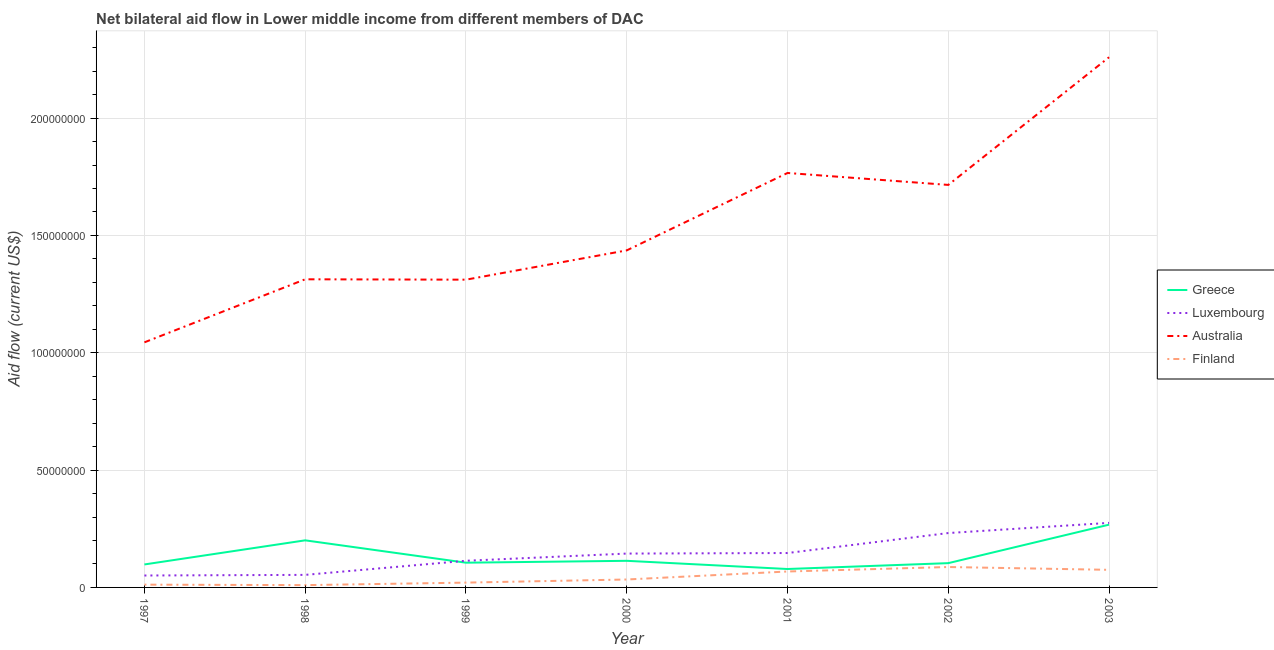How many different coloured lines are there?
Your answer should be compact. 4. Does the line corresponding to amount of aid given by luxembourg intersect with the line corresponding to amount of aid given by australia?
Keep it short and to the point. No. What is the amount of aid given by greece in 2002?
Offer a very short reply. 1.04e+07. Across all years, what is the maximum amount of aid given by greece?
Your response must be concise. 2.68e+07. Across all years, what is the minimum amount of aid given by finland?
Your response must be concise. 9.80e+05. In which year was the amount of aid given by greece maximum?
Make the answer very short. 2003. What is the total amount of aid given by greece in the graph?
Offer a very short reply. 9.67e+07. What is the difference between the amount of aid given by luxembourg in 1997 and that in 1999?
Keep it short and to the point. -6.28e+06. What is the difference between the amount of aid given by finland in 1997 and the amount of aid given by luxembourg in 2003?
Your answer should be very brief. -2.63e+07. What is the average amount of aid given by australia per year?
Your answer should be very brief. 1.55e+08. In the year 1997, what is the difference between the amount of aid given by australia and amount of aid given by greece?
Provide a short and direct response. 9.47e+07. What is the ratio of the amount of aid given by greece in 1997 to that in 2003?
Make the answer very short. 0.37. What is the difference between the highest and the second highest amount of aid given by australia?
Keep it short and to the point. 4.93e+07. What is the difference between the highest and the lowest amount of aid given by luxembourg?
Your answer should be very brief. 2.24e+07. In how many years, is the amount of aid given by luxembourg greater than the average amount of aid given by luxembourg taken over all years?
Your answer should be very brief. 3. Is the sum of the amount of aid given by australia in 2001 and 2003 greater than the maximum amount of aid given by finland across all years?
Your answer should be very brief. Yes. Is it the case that in every year, the sum of the amount of aid given by australia and amount of aid given by luxembourg is greater than the sum of amount of aid given by finland and amount of aid given by greece?
Your answer should be very brief. No. Does the amount of aid given by australia monotonically increase over the years?
Offer a very short reply. No. Is the amount of aid given by greece strictly greater than the amount of aid given by luxembourg over the years?
Offer a terse response. No. What is the difference between two consecutive major ticks on the Y-axis?
Ensure brevity in your answer.  5.00e+07. Does the graph contain any zero values?
Your answer should be compact. No. Where does the legend appear in the graph?
Ensure brevity in your answer.  Center right. How many legend labels are there?
Your answer should be very brief. 4. How are the legend labels stacked?
Ensure brevity in your answer.  Vertical. What is the title of the graph?
Your answer should be compact. Net bilateral aid flow in Lower middle income from different members of DAC. Does "Interest Payments" appear as one of the legend labels in the graph?
Your answer should be compact. No. What is the Aid flow (current US$) of Greece in 1997?
Provide a succinct answer. 9.79e+06. What is the Aid flow (current US$) in Luxembourg in 1997?
Make the answer very short. 5.08e+06. What is the Aid flow (current US$) of Australia in 1997?
Offer a terse response. 1.04e+08. What is the Aid flow (current US$) of Finland in 1997?
Your answer should be compact. 1.18e+06. What is the Aid flow (current US$) of Greece in 1998?
Give a very brief answer. 2.01e+07. What is the Aid flow (current US$) of Luxembourg in 1998?
Keep it short and to the point. 5.35e+06. What is the Aid flow (current US$) in Australia in 1998?
Your answer should be compact. 1.31e+08. What is the Aid flow (current US$) in Finland in 1998?
Ensure brevity in your answer.  9.80e+05. What is the Aid flow (current US$) in Greece in 1999?
Make the answer very short. 1.05e+07. What is the Aid flow (current US$) in Luxembourg in 1999?
Your answer should be compact. 1.14e+07. What is the Aid flow (current US$) in Australia in 1999?
Give a very brief answer. 1.31e+08. What is the Aid flow (current US$) of Finland in 1999?
Provide a succinct answer. 2.05e+06. What is the Aid flow (current US$) of Greece in 2000?
Keep it short and to the point. 1.13e+07. What is the Aid flow (current US$) in Luxembourg in 2000?
Your answer should be compact. 1.44e+07. What is the Aid flow (current US$) of Australia in 2000?
Ensure brevity in your answer.  1.44e+08. What is the Aid flow (current US$) of Finland in 2000?
Give a very brief answer. 3.38e+06. What is the Aid flow (current US$) in Greece in 2001?
Your answer should be very brief. 7.85e+06. What is the Aid flow (current US$) in Luxembourg in 2001?
Keep it short and to the point. 1.47e+07. What is the Aid flow (current US$) of Australia in 2001?
Your response must be concise. 1.77e+08. What is the Aid flow (current US$) in Finland in 2001?
Your answer should be very brief. 6.79e+06. What is the Aid flow (current US$) in Greece in 2002?
Provide a short and direct response. 1.04e+07. What is the Aid flow (current US$) in Luxembourg in 2002?
Provide a short and direct response. 2.32e+07. What is the Aid flow (current US$) of Australia in 2002?
Offer a terse response. 1.72e+08. What is the Aid flow (current US$) of Finland in 2002?
Ensure brevity in your answer.  8.70e+06. What is the Aid flow (current US$) in Greece in 2003?
Ensure brevity in your answer.  2.68e+07. What is the Aid flow (current US$) of Luxembourg in 2003?
Provide a short and direct response. 2.75e+07. What is the Aid flow (current US$) in Australia in 2003?
Provide a short and direct response. 2.26e+08. What is the Aid flow (current US$) in Finland in 2003?
Make the answer very short. 7.50e+06. Across all years, what is the maximum Aid flow (current US$) in Greece?
Your answer should be very brief. 2.68e+07. Across all years, what is the maximum Aid flow (current US$) in Luxembourg?
Provide a succinct answer. 2.75e+07. Across all years, what is the maximum Aid flow (current US$) in Australia?
Provide a succinct answer. 2.26e+08. Across all years, what is the maximum Aid flow (current US$) of Finland?
Provide a succinct answer. 8.70e+06. Across all years, what is the minimum Aid flow (current US$) of Greece?
Provide a short and direct response. 7.85e+06. Across all years, what is the minimum Aid flow (current US$) in Luxembourg?
Your response must be concise. 5.08e+06. Across all years, what is the minimum Aid flow (current US$) of Australia?
Keep it short and to the point. 1.04e+08. Across all years, what is the minimum Aid flow (current US$) of Finland?
Your response must be concise. 9.80e+05. What is the total Aid flow (current US$) of Greece in the graph?
Ensure brevity in your answer.  9.67e+07. What is the total Aid flow (current US$) in Luxembourg in the graph?
Offer a terse response. 1.02e+08. What is the total Aid flow (current US$) of Australia in the graph?
Your response must be concise. 1.08e+09. What is the total Aid flow (current US$) in Finland in the graph?
Your response must be concise. 3.06e+07. What is the difference between the Aid flow (current US$) of Greece in 1997 and that in 1998?
Your answer should be compact. -1.03e+07. What is the difference between the Aid flow (current US$) in Australia in 1997 and that in 1998?
Make the answer very short. -2.69e+07. What is the difference between the Aid flow (current US$) in Greece in 1997 and that in 1999?
Keep it short and to the point. -7.50e+05. What is the difference between the Aid flow (current US$) of Luxembourg in 1997 and that in 1999?
Ensure brevity in your answer.  -6.28e+06. What is the difference between the Aid flow (current US$) of Australia in 1997 and that in 1999?
Your answer should be very brief. -2.67e+07. What is the difference between the Aid flow (current US$) in Finland in 1997 and that in 1999?
Your answer should be very brief. -8.70e+05. What is the difference between the Aid flow (current US$) of Greece in 1997 and that in 2000?
Provide a short and direct response. -1.55e+06. What is the difference between the Aid flow (current US$) of Luxembourg in 1997 and that in 2000?
Ensure brevity in your answer.  -9.35e+06. What is the difference between the Aid flow (current US$) of Australia in 1997 and that in 2000?
Provide a succinct answer. -3.92e+07. What is the difference between the Aid flow (current US$) of Finland in 1997 and that in 2000?
Provide a short and direct response. -2.20e+06. What is the difference between the Aid flow (current US$) in Greece in 1997 and that in 2001?
Give a very brief answer. 1.94e+06. What is the difference between the Aid flow (current US$) of Luxembourg in 1997 and that in 2001?
Offer a terse response. -9.58e+06. What is the difference between the Aid flow (current US$) in Australia in 1997 and that in 2001?
Your answer should be very brief. -7.22e+07. What is the difference between the Aid flow (current US$) of Finland in 1997 and that in 2001?
Offer a terse response. -5.61e+06. What is the difference between the Aid flow (current US$) in Greece in 1997 and that in 2002?
Your response must be concise. -5.60e+05. What is the difference between the Aid flow (current US$) of Luxembourg in 1997 and that in 2002?
Make the answer very short. -1.81e+07. What is the difference between the Aid flow (current US$) of Australia in 1997 and that in 2002?
Make the answer very short. -6.71e+07. What is the difference between the Aid flow (current US$) of Finland in 1997 and that in 2002?
Make the answer very short. -7.52e+06. What is the difference between the Aid flow (current US$) in Greece in 1997 and that in 2003?
Provide a short and direct response. -1.70e+07. What is the difference between the Aid flow (current US$) of Luxembourg in 1997 and that in 2003?
Ensure brevity in your answer.  -2.24e+07. What is the difference between the Aid flow (current US$) in Australia in 1997 and that in 2003?
Give a very brief answer. -1.22e+08. What is the difference between the Aid flow (current US$) in Finland in 1997 and that in 2003?
Provide a succinct answer. -6.32e+06. What is the difference between the Aid flow (current US$) of Greece in 1998 and that in 1999?
Provide a succinct answer. 9.53e+06. What is the difference between the Aid flow (current US$) of Luxembourg in 1998 and that in 1999?
Make the answer very short. -6.01e+06. What is the difference between the Aid flow (current US$) in Australia in 1998 and that in 1999?
Your response must be concise. 1.60e+05. What is the difference between the Aid flow (current US$) of Finland in 1998 and that in 1999?
Offer a terse response. -1.07e+06. What is the difference between the Aid flow (current US$) of Greece in 1998 and that in 2000?
Your response must be concise. 8.73e+06. What is the difference between the Aid flow (current US$) of Luxembourg in 1998 and that in 2000?
Provide a succinct answer. -9.08e+06. What is the difference between the Aid flow (current US$) of Australia in 1998 and that in 2000?
Ensure brevity in your answer.  -1.23e+07. What is the difference between the Aid flow (current US$) of Finland in 1998 and that in 2000?
Your answer should be very brief. -2.40e+06. What is the difference between the Aid flow (current US$) of Greece in 1998 and that in 2001?
Your answer should be very brief. 1.22e+07. What is the difference between the Aid flow (current US$) in Luxembourg in 1998 and that in 2001?
Your answer should be very brief. -9.31e+06. What is the difference between the Aid flow (current US$) of Australia in 1998 and that in 2001?
Make the answer very short. -4.53e+07. What is the difference between the Aid flow (current US$) of Finland in 1998 and that in 2001?
Your answer should be very brief. -5.81e+06. What is the difference between the Aid flow (current US$) of Greece in 1998 and that in 2002?
Provide a short and direct response. 9.72e+06. What is the difference between the Aid flow (current US$) in Luxembourg in 1998 and that in 2002?
Your response must be concise. -1.78e+07. What is the difference between the Aid flow (current US$) of Australia in 1998 and that in 2002?
Keep it short and to the point. -4.02e+07. What is the difference between the Aid flow (current US$) of Finland in 1998 and that in 2002?
Your answer should be compact. -7.72e+06. What is the difference between the Aid flow (current US$) in Greece in 1998 and that in 2003?
Offer a terse response. -6.68e+06. What is the difference between the Aid flow (current US$) in Luxembourg in 1998 and that in 2003?
Provide a short and direct response. -2.22e+07. What is the difference between the Aid flow (current US$) of Australia in 1998 and that in 2003?
Keep it short and to the point. -9.46e+07. What is the difference between the Aid flow (current US$) in Finland in 1998 and that in 2003?
Provide a succinct answer. -6.52e+06. What is the difference between the Aid flow (current US$) of Greece in 1999 and that in 2000?
Provide a short and direct response. -8.00e+05. What is the difference between the Aid flow (current US$) in Luxembourg in 1999 and that in 2000?
Ensure brevity in your answer.  -3.07e+06. What is the difference between the Aid flow (current US$) of Australia in 1999 and that in 2000?
Ensure brevity in your answer.  -1.25e+07. What is the difference between the Aid flow (current US$) in Finland in 1999 and that in 2000?
Provide a succinct answer. -1.33e+06. What is the difference between the Aid flow (current US$) in Greece in 1999 and that in 2001?
Your answer should be compact. 2.69e+06. What is the difference between the Aid flow (current US$) in Luxembourg in 1999 and that in 2001?
Offer a terse response. -3.30e+06. What is the difference between the Aid flow (current US$) in Australia in 1999 and that in 2001?
Offer a terse response. -4.55e+07. What is the difference between the Aid flow (current US$) in Finland in 1999 and that in 2001?
Make the answer very short. -4.74e+06. What is the difference between the Aid flow (current US$) in Luxembourg in 1999 and that in 2002?
Provide a succinct answer. -1.18e+07. What is the difference between the Aid flow (current US$) in Australia in 1999 and that in 2002?
Make the answer very short. -4.04e+07. What is the difference between the Aid flow (current US$) of Finland in 1999 and that in 2002?
Offer a terse response. -6.65e+06. What is the difference between the Aid flow (current US$) of Greece in 1999 and that in 2003?
Give a very brief answer. -1.62e+07. What is the difference between the Aid flow (current US$) of Luxembourg in 1999 and that in 2003?
Offer a very short reply. -1.62e+07. What is the difference between the Aid flow (current US$) of Australia in 1999 and that in 2003?
Your answer should be compact. -9.48e+07. What is the difference between the Aid flow (current US$) of Finland in 1999 and that in 2003?
Give a very brief answer. -5.45e+06. What is the difference between the Aid flow (current US$) in Greece in 2000 and that in 2001?
Your answer should be very brief. 3.49e+06. What is the difference between the Aid flow (current US$) in Luxembourg in 2000 and that in 2001?
Offer a terse response. -2.30e+05. What is the difference between the Aid flow (current US$) in Australia in 2000 and that in 2001?
Offer a terse response. -3.30e+07. What is the difference between the Aid flow (current US$) of Finland in 2000 and that in 2001?
Your answer should be compact. -3.41e+06. What is the difference between the Aid flow (current US$) in Greece in 2000 and that in 2002?
Make the answer very short. 9.90e+05. What is the difference between the Aid flow (current US$) in Luxembourg in 2000 and that in 2002?
Your answer should be compact. -8.75e+06. What is the difference between the Aid flow (current US$) of Australia in 2000 and that in 2002?
Give a very brief answer. -2.79e+07. What is the difference between the Aid flow (current US$) of Finland in 2000 and that in 2002?
Give a very brief answer. -5.32e+06. What is the difference between the Aid flow (current US$) of Greece in 2000 and that in 2003?
Offer a terse response. -1.54e+07. What is the difference between the Aid flow (current US$) in Luxembourg in 2000 and that in 2003?
Offer a very short reply. -1.31e+07. What is the difference between the Aid flow (current US$) of Australia in 2000 and that in 2003?
Your response must be concise. -8.23e+07. What is the difference between the Aid flow (current US$) of Finland in 2000 and that in 2003?
Provide a succinct answer. -4.12e+06. What is the difference between the Aid flow (current US$) in Greece in 2001 and that in 2002?
Ensure brevity in your answer.  -2.50e+06. What is the difference between the Aid flow (current US$) in Luxembourg in 2001 and that in 2002?
Offer a terse response. -8.52e+06. What is the difference between the Aid flow (current US$) of Australia in 2001 and that in 2002?
Your answer should be compact. 5.09e+06. What is the difference between the Aid flow (current US$) of Finland in 2001 and that in 2002?
Offer a terse response. -1.91e+06. What is the difference between the Aid flow (current US$) of Greece in 2001 and that in 2003?
Provide a succinct answer. -1.89e+07. What is the difference between the Aid flow (current US$) of Luxembourg in 2001 and that in 2003?
Make the answer very short. -1.28e+07. What is the difference between the Aid flow (current US$) in Australia in 2001 and that in 2003?
Make the answer very short. -4.93e+07. What is the difference between the Aid flow (current US$) of Finland in 2001 and that in 2003?
Keep it short and to the point. -7.10e+05. What is the difference between the Aid flow (current US$) of Greece in 2002 and that in 2003?
Offer a terse response. -1.64e+07. What is the difference between the Aid flow (current US$) in Luxembourg in 2002 and that in 2003?
Keep it short and to the point. -4.33e+06. What is the difference between the Aid flow (current US$) of Australia in 2002 and that in 2003?
Make the answer very short. -5.44e+07. What is the difference between the Aid flow (current US$) of Finland in 2002 and that in 2003?
Provide a short and direct response. 1.20e+06. What is the difference between the Aid flow (current US$) in Greece in 1997 and the Aid flow (current US$) in Luxembourg in 1998?
Your response must be concise. 4.44e+06. What is the difference between the Aid flow (current US$) in Greece in 1997 and the Aid flow (current US$) in Australia in 1998?
Your answer should be very brief. -1.22e+08. What is the difference between the Aid flow (current US$) in Greece in 1997 and the Aid flow (current US$) in Finland in 1998?
Ensure brevity in your answer.  8.81e+06. What is the difference between the Aid flow (current US$) of Luxembourg in 1997 and the Aid flow (current US$) of Australia in 1998?
Your response must be concise. -1.26e+08. What is the difference between the Aid flow (current US$) of Luxembourg in 1997 and the Aid flow (current US$) of Finland in 1998?
Offer a very short reply. 4.10e+06. What is the difference between the Aid flow (current US$) of Australia in 1997 and the Aid flow (current US$) of Finland in 1998?
Offer a very short reply. 1.03e+08. What is the difference between the Aid flow (current US$) in Greece in 1997 and the Aid flow (current US$) in Luxembourg in 1999?
Keep it short and to the point. -1.57e+06. What is the difference between the Aid flow (current US$) in Greece in 1997 and the Aid flow (current US$) in Australia in 1999?
Your response must be concise. -1.21e+08. What is the difference between the Aid flow (current US$) of Greece in 1997 and the Aid flow (current US$) of Finland in 1999?
Your response must be concise. 7.74e+06. What is the difference between the Aid flow (current US$) in Luxembourg in 1997 and the Aid flow (current US$) in Australia in 1999?
Make the answer very short. -1.26e+08. What is the difference between the Aid flow (current US$) of Luxembourg in 1997 and the Aid flow (current US$) of Finland in 1999?
Ensure brevity in your answer.  3.03e+06. What is the difference between the Aid flow (current US$) in Australia in 1997 and the Aid flow (current US$) in Finland in 1999?
Provide a short and direct response. 1.02e+08. What is the difference between the Aid flow (current US$) of Greece in 1997 and the Aid flow (current US$) of Luxembourg in 2000?
Your response must be concise. -4.64e+06. What is the difference between the Aid flow (current US$) of Greece in 1997 and the Aid flow (current US$) of Australia in 2000?
Your response must be concise. -1.34e+08. What is the difference between the Aid flow (current US$) of Greece in 1997 and the Aid flow (current US$) of Finland in 2000?
Give a very brief answer. 6.41e+06. What is the difference between the Aid flow (current US$) of Luxembourg in 1997 and the Aid flow (current US$) of Australia in 2000?
Provide a short and direct response. -1.39e+08. What is the difference between the Aid flow (current US$) in Luxembourg in 1997 and the Aid flow (current US$) in Finland in 2000?
Offer a terse response. 1.70e+06. What is the difference between the Aid flow (current US$) of Australia in 1997 and the Aid flow (current US$) of Finland in 2000?
Keep it short and to the point. 1.01e+08. What is the difference between the Aid flow (current US$) in Greece in 1997 and the Aid flow (current US$) in Luxembourg in 2001?
Your answer should be compact. -4.87e+06. What is the difference between the Aid flow (current US$) in Greece in 1997 and the Aid flow (current US$) in Australia in 2001?
Give a very brief answer. -1.67e+08. What is the difference between the Aid flow (current US$) in Greece in 1997 and the Aid flow (current US$) in Finland in 2001?
Your answer should be compact. 3.00e+06. What is the difference between the Aid flow (current US$) of Luxembourg in 1997 and the Aid flow (current US$) of Australia in 2001?
Your answer should be very brief. -1.72e+08. What is the difference between the Aid flow (current US$) of Luxembourg in 1997 and the Aid flow (current US$) of Finland in 2001?
Provide a succinct answer. -1.71e+06. What is the difference between the Aid flow (current US$) in Australia in 1997 and the Aid flow (current US$) in Finland in 2001?
Offer a terse response. 9.77e+07. What is the difference between the Aid flow (current US$) of Greece in 1997 and the Aid flow (current US$) of Luxembourg in 2002?
Give a very brief answer. -1.34e+07. What is the difference between the Aid flow (current US$) of Greece in 1997 and the Aid flow (current US$) of Australia in 2002?
Provide a succinct answer. -1.62e+08. What is the difference between the Aid flow (current US$) in Greece in 1997 and the Aid flow (current US$) in Finland in 2002?
Give a very brief answer. 1.09e+06. What is the difference between the Aid flow (current US$) in Luxembourg in 1997 and the Aid flow (current US$) in Australia in 2002?
Provide a short and direct response. -1.66e+08. What is the difference between the Aid flow (current US$) of Luxembourg in 1997 and the Aid flow (current US$) of Finland in 2002?
Provide a succinct answer. -3.62e+06. What is the difference between the Aid flow (current US$) of Australia in 1997 and the Aid flow (current US$) of Finland in 2002?
Keep it short and to the point. 9.58e+07. What is the difference between the Aid flow (current US$) in Greece in 1997 and the Aid flow (current US$) in Luxembourg in 2003?
Keep it short and to the point. -1.77e+07. What is the difference between the Aid flow (current US$) in Greece in 1997 and the Aid flow (current US$) in Australia in 2003?
Your response must be concise. -2.16e+08. What is the difference between the Aid flow (current US$) in Greece in 1997 and the Aid flow (current US$) in Finland in 2003?
Provide a succinct answer. 2.29e+06. What is the difference between the Aid flow (current US$) of Luxembourg in 1997 and the Aid flow (current US$) of Australia in 2003?
Your answer should be very brief. -2.21e+08. What is the difference between the Aid flow (current US$) in Luxembourg in 1997 and the Aid flow (current US$) in Finland in 2003?
Offer a terse response. -2.42e+06. What is the difference between the Aid flow (current US$) in Australia in 1997 and the Aid flow (current US$) in Finland in 2003?
Your answer should be compact. 9.70e+07. What is the difference between the Aid flow (current US$) in Greece in 1998 and the Aid flow (current US$) in Luxembourg in 1999?
Your answer should be very brief. 8.71e+06. What is the difference between the Aid flow (current US$) of Greece in 1998 and the Aid flow (current US$) of Australia in 1999?
Provide a succinct answer. -1.11e+08. What is the difference between the Aid flow (current US$) in Greece in 1998 and the Aid flow (current US$) in Finland in 1999?
Your answer should be very brief. 1.80e+07. What is the difference between the Aid flow (current US$) in Luxembourg in 1998 and the Aid flow (current US$) in Australia in 1999?
Your response must be concise. -1.26e+08. What is the difference between the Aid flow (current US$) of Luxembourg in 1998 and the Aid flow (current US$) of Finland in 1999?
Keep it short and to the point. 3.30e+06. What is the difference between the Aid flow (current US$) in Australia in 1998 and the Aid flow (current US$) in Finland in 1999?
Your response must be concise. 1.29e+08. What is the difference between the Aid flow (current US$) of Greece in 1998 and the Aid flow (current US$) of Luxembourg in 2000?
Give a very brief answer. 5.64e+06. What is the difference between the Aid flow (current US$) in Greece in 1998 and the Aid flow (current US$) in Australia in 2000?
Provide a succinct answer. -1.24e+08. What is the difference between the Aid flow (current US$) in Greece in 1998 and the Aid flow (current US$) in Finland in 2000?
Provide a short and direct response. 1.67e+07. What is the difference between the Aid flow (current US$) of Luxembourg in 1998 and the Aid flow (current US$) of Australia in 2000?
Your answer should be very brief. -1.38e+08. What is the difference between the Aid flow (current US$) in Luxembourg in 1998 and the Aid flow (current US$) in Finland in 2000?
Make the answer very short. 1.97e+06. What is the difference between the Aid flow (current US$) of Australia in 1998 and the Aid flow (current US$) of Finland in 2000?
Give a very brief answer. 1.28e+08. What is the difference between the Aid flow (current US$) in Greece in 1998 and the Aid flow (current US$) in Luxembourg in 2001?
Keep it short and to the point. 5.41e+06. What is the difference between the Aid flow (current US$) in Greece in 1998 and the Aid flow (current US$) in Australia in 2001?
Your answer should be very brief. -1.57e+08. What is the difference between the Aid flow (current US$) of Greece in 1998 and the Aid flow (current US$) of Finland in 2001?
Your response must be concise. 1.33e+07. What is the difference between the Aid flow (current US$) in Luxembourg in 1998 and the Aid flow (current US$) in Australia in 2001?
Your response must be concise. -1.71e+08. What is the difference between the Aid flow (current US$) of Luxembourg in 1998 and the Aid flow (current US$) of Finland in 2001?
Your response must be concise. -1.44e+06. What is the difference between the Aid flow (current US$) in Australia in 1998 and the Aid flow (current US$) in Finland in 2001?
Make the answer very short. 1.25e+08. What is the difference between the Aid flow (current US$) of Greece in 1998 and the Aid flow (current US$) of Luxembourg in 2002?
Ensure brevity in your answer.  -3.11e+06. What is the difference between the Aid flow (current US$) in Greece in 1998 and the Aid flow (current US$) in Australia in 2002?
Your answer should be compact. -1.51e+08. What is the difference between the Aid flow (current US$) of Greece in 1998 and the Aid flow (current US$) of Finland in 2002?
Provide a succinct answer. 1.14e+07. What is the difference between the Aid flow (current US$) of Luxembourg in 1998 and the Aid flow (current US$) of Australia in 2002?
Your response must be concise. -1.66e+08. What is the difference between the Aid flow (current US$) in Luxembourg in 1998 and the Aid flow (current US$) in Finland in 2002?
Your response must be concise. -3.35e+06. What is the difference between the Aid flow (current US$) in Australia in 1998 and the Aid flow (current US$) in Finland in 2002?
Provide a succinct answer. 1.23e+08. What is the difference between the Aid flow (current US$) in Greece in 1998 and the Aid flow (current US$) in Luxembourg in 2003?
Provide a succinct answer. -7.44e+06. What is the difference between the Aid flow (current US$) of Greece in 1998 and the Aid flow (current US$) of Australia in 2003?
Give a very brief answer. -2.06e+08. What is the difference between the Aid flow (current US$) of Greece in 1998 and the Aid flow (current US$) of Finland in 2003?
Give a very brief answer. 1.26e+07. What is the difference between the Aid flow (current US$) of Luxembourg in 1998 and the Aid flow (current US$) of Australia in 2003?
Your answer should be compact. -2.21e+08. What is the difference between the Aid flow (current US$) in Luxembourg in 1998 and the Aid flow (current US$) in Finland in 2003?
Provide a succinct answer. -2.15e+06. What is the difference between the Aid flow (current US$) of Australia in 1998 and the Aid flow (current US$) of Finland in 2003?
Your answer should be compact. 1.24e+08. What is the difference between the Aid flow (current US$) of Greece in 1999 and the Aid flow (current US$) of Luxembourg in 2000?
Your answer should be very brief. -3.89e+06. What is the difference between the Aid flow (current US$) of Greece in 1999 and the Aid flow (current US$) of Australia in 2000?
Ensure brevity in your answer.  -1.33e+08. What is the difference between the Aid flow (current US$) in Greece in 1999 and the Aid flow (current US$) in Finland in 2000?
Your answer should be compact. 7.16e+06. What is the difference between the Aid flow (current US$) in Luxembourg in 1999 and the Aid flow (current US$) in Australia in 2000?
Your answer should be very brief. -1.32e+08. What is the difference between the Aid flow (current US$) of Luxembourg in 1999 and the Aid flow (current US$) of Finland in 2000?
Your response must be concise. 7.98e+06. What is the difference between the Aid flow (current US$) in Australia in 1999 and the Aid flow (current US$) in Finland in 2000?
Provide a succinct answer. 1.28e+08. What is the difference between the Aid flow (current US$) in Greece in 1999 and the Aid flow (current US$) in Luxembourg in 2001?
Keep it short and to the point. -4.12e+06. What is the difference between the Aid flow (current US$) in Greece in 1999 and the Aid flow (current US$) in Australia in 2001?
Provide a succinct answer. -1.66e+08. What is the difference between the Aid flow (current US$) of Greece in 1999 and the Aid flow (current US$) of Finland in 2001?
Ensure brevity in your answer.  3.75e+06. What is the difference between the Aid flow (current US$) of Luxembourg in 1999 and the Aid flow (current US$) of Australia in 2001?
Provide a succinct answer. -1.65e+08. What is the difference between the Aid flow (current US$) of Luxembourg in 1999 and the Aid flow (current US$) of Finland in 2001?
Provide a succinct answer. 4.57e+06. What is the difference between the Aid flow (current US$) of Australia in 1999 and the Aid flow (current US$) of Finland in 2001?
Provide a short and direct response. 1.24e+08. What is the difference between the Aid flow (current US$) in Greece in 1999 and the Aid flow (current US$) in Luxembourg in 2002?
Your answer should be very brief. -1.26e+07. What is the difference between the Aid flow (current US$) in Greece in 1999 and the Aid flow (current US$) in Australia in 2002?
Ensure brevity in your answer.  -1.61e+08. What is the difference between the Aid flow (current US$) of Greece in 1999 and the Aid flow (current US$) of Finland in 2002?
Your answer should be compact. 1.84e+06. What is the difference between the Aid flow (current US$) in Luxembourg in 1999 and the Aid flow (current US$) in Australia in 2002?
Your answer should be very brief. -1.60e+08. What is the difference between the Aid flow (current US$) in Luxembourg in 1999 and the Aid flow (current US$) in Finland in 2002?
Keep it short and to the point. 2.66e+06. What is the difference between the Aid flow (current US$) in Australia in 1999 and the Aid flow (current US$) in Finland in 2002?
Give a very brief answer. 1.22e+08. What is the difference between the Aid flow (current US$) of Greece in 1999 and the Aid flow (current US$) of Luxembourg in 2003?
Offer a terse response. -1.70e+07. What is the difference between the Aid flow (current US$) of Greece in 1999 and the Aid flow (current US$) of Australia in 2003?
Your answer should be compact. -2.15e+08. What is the difference between the Aid flow (current US$) in Greece in 1999 and the Aid flow (current US$) in Finland in 2003?
Your response must be concise. 3.04e+06. What is the difference between the Aid flow (current US$) in Luxembourg in 1999 and the Aid flow (current US$) in Australia in 2003?
Give a very brief answer. -2.15e+08. What is the difference between the Aid flow (current US$) of Luxembourg in 1999 and the Aid flow (current US$) of Finland in 2003?
Give a very brief answer. 3.86e+06. What is the difference between the Aid flow (current US$) of Australia in 1999 and the Aid flow (current US$) of Finland in 2003?
Offer a very short reply. 1.24e+08. What is the difference between the Aid flow (current US$) in Greece in 2000 and the Aid flow (current US$) in Luxembourg in 2001?
Offer a very short reply. -3.32e+06. What is the difference between the Aid flow (current US$) in Greece in 2000 and the Aid flow (current US$) in Australia in 2001?
Offer a terse response. -1.65e+08. What is the difference between the Aid flow (current US$) of Greece in 2000 and the Aid flow (current US$) of Finland in 2001?
Your response must be concise. 4.55e+06. What is the difference between the Aid flow (current US$) in Luxembourg in 2000 and the Aid flow (current US$) in Australia in 2001?
Provide a succinct answer. -1.62e+08. What is the difference between the Aid flow (current US$) of Luxembourg in 2000 and the Aid flow (current US$) of Finland in 2001?
Keep it short and to the point. 7.64e+06. What is the difference between the Aid flow (current US$) of Australia in 2000 and the Aid flow (current US$) of Finland in 2001?
Your answer should be compact. 1.37e+08. What is the difference between the Aid flow (current US$) of Greece in 2000 and the Aid flow (current US$) of Luxembourg in 2002?
Offer a very short reply. -1.18e+07. What is the difference between the Aid flow (current US$) in Greece in 2000 and the Aid flow (current US$) in Australia in 2002?
Keep it short and to the point. -1.60e+08. What is the difference between the Aid flow (current US$) of Greece in 2000 and the Aid flow (current US$) of Finland in 2002?
Make the answer very short. 2.64e+06. What is the difference between the Aid flow (current US$) of Luxembourg in 2000 and the Aid flow (current US$) of Australia in 2002?
Ensure brevity in your answer.  -1.57e+08. What is the difference between the Aid flow (current US$) in Luxembourg in 2000 and the Aid flow (current US$) in Finland in 2002?
Your answer should be compact. 5.73e+06. What is the difference between the Aid flow (current US$) of Australia in 2000 and the Aid flow (current US$) of Finland in 2002?
Make the answer very short. 1.35e+08. What is the difference between the Aid flow (current US$) of Greece in 2000 and the Aid flow (current US$) of Luxembourg in 2003?
Your answer should be very brief. -1.62e+07. What is the difference between the Aid flow (current US$) of Greece in 2000 and the Aid flow (current US$) of Australia in 2003?
Give a very brief answer. -2.15e+08. What is the difference between the Aid flow (current US$) of Greece in 2000 and the Aid flow (current US$) of Finland in 2003?
Keep it short and to the point. 3.84e+06. What is the difference between the Aid flow (current US$) in Luxembourg in 2000 and the Aid flow (current US$) in Australia in 2003?
Your response must be concise. -2.12e+08. What is the difference between the Aid flow (current US$) in Luxembourg in 2000 and the Aid flow (current US$) in Finland in 2003?
Ensure brevity in your answer.  6.93e+06. What is the difference between the Aid flow (current US$) of Australia in 2000 and the Aid flow (current US$) of Finland in 2003?
Offer a very short reply. 1.36e+08. What is the difference between the Aid flow (current US$) of Greece in 2001 and the Aid flow (current US$) of Luxembourg in 2002?
Offer a very short reply. -1.53e+07. What is the difference between the Aid flow (current US$) in Greece in 2001 and the Aid flow (current US$) in Australia in 2002?
Offer a terse response. -1.64e+08. What is the difference between the Aid flow (current US$) in Greece in 2001 and the Aid flow (current US$) in Finland in 2002?
Ensure brevity in your answer.  -8.50e+05. What is the difference between the Aid flow (current US$) in Luxembourg in 2001 and the Aid flow (current US$) in Australia in 2002?
Your answer should be compact. -1.57e+08. What is the difference between the Aid flow (current US$) of Luxembourg in 2001 and the Aid flow (current US$) of Finland in 2002?
Your answer should be very brief. 5.96e+06. What is the difference between the Aid flow (current US$) in Australia in 2001 and the Aid flow (current US$) in Finland in 2002?
Your response must be concise. 1.68e+08. What is the difference between the Aid flow (current US$) in Greece in 2001 and the Aid flow (current US$) in Luxembourg in 2003?
Make the answer very short. -1.97e+07. What is the difference between the Aid flow (current US$) of Greece in 2001 and the Aid flow (current US$) of Australia in 2003?
Your answer should be very brief. -2.18e+08. What is the difference between the Aid flow (current US$) in Luxembourg in 2001 and the Aid flow (current US$) in Australia in 2003?
Your answer should be compact. -2.11e+08. What is the difference between the Aid flow (current US$) of Luxembourg in 2001 and the Aid flow (current US$) of Finland in 2003?
Provide a short and direct response. 7.16e+06. What is the difference between the Aid flow (current US$) of Australia in 2001 and the Aid flow (current US$) of Finland in 2003?
Give a very brief answer. 1.69e+08. What is the difference between the Aid flow (current US$) in Greece in 2002 and the Aid flow (current US$) in Luxembourg in 2003?
Ensure brevity in your answer.  -1.72e+07. What is the difference between the Aid flow (current US$) of Greece in 2002 and the Aid flow (current US$) of Australia in 2003?
Your response must be concise. -2.16e+08. What is the difference between the Aid flow (current US$) of Greece in 2002 and the Aid flow (current US$) of Finland in 2003?
Offer a terse response. 2.85e+06. What is the difference between the Aid flow (current US$) in Luxembourg in 2002 and the Aid flow (current US$) in Australia in 2003?
Keep it short and to the point. -2.03e+08. What is the difference between the Aid flow (current US$) in Luxembourg in 2002 and the Aid flow (current US$) in Finland in 2003?
Your response must be concise. 1.57e+07. What is the difference between the Aid flow (current US$) in Australia in 2002 and the Aid flow (current US$) in Finland in 2003?
Give a very brief answer. 1.64e+08. What is the average Aid flow (current US$) in Greece per year?
Ensure brevity in your answer.  1.38e+07. What is the average Aid flow (current US$) in Luxembourg per year?
Ensure brevity in your answer.  1.45e+07. What is the average Aid flow (current US$) of Australia per year?
Your answer should be very brief. 1.55e+08. What is the average Aid flow (current US$) of Finland per year?
Provide a short and direct response. 4.37e+06. In the year 1997, what is the difference between the Aid flow (current US$) in Greece and Aid flow (current US$) in Luxembourg?
Provide a succinct answer. 4.71e+06. In the year 1997, what is the difference between the Aid flow (current US$) in Greece and Aid flow (current US$) in Australia?
Provide a short and direct response. -9.47e+07. In the year 1997, what is the difference between the Aid flow (current US$) of Greece and Aid flow (current US$) of Finland?
Offer a terse response. 8.61e+06. In the year 1997, what is the difference between the Aid flow (current US$) in Luxembourg and Aid flow (current US$) in Australia?
Make the answer very short. -9.94e+07. In the year 1997, what is the difference between the Aid flow (current US$) in Luxembourg and Aid flow (current US$) in Finland?
Ensure brevity in your answer.  3.90e+06. In the year 1997, what is the difference between the Aid flow (current US$) in Australia and Aid flow (current US$) in Finland?
Make the answer very short. 1.03e+08. In the year 1998, what is the difference between the Aid flow (current US$) of Greece and Aid flow (current US$) of Luxembourg?
Offer a very short reply. 1.47e+07. In the year 1998, what is the difference between the Aid flow (current US$) of Greece and Aid flow (current US$) of Australia?
Keep it short and to the point. -1.11e+08. In the year 1998, what is the difference between the Aid flow (current US$) of Greece and Aid flow (current US$) of Finland?
Provide a succinct answer. 1.91e+07. In the year 1998, what is the difference between the Aid flow (current US$) of Luxembourg and Aid flow (current US$) of Australia?
Your answer should be very brief. -1.26e+08. In the year 1998, what is the difference between the Aid flow (current US$) of Luxembourg and Aid flow (current US$) of Finland?
Make the answer very short. 4.37e+06. In the year 1998, what is the difference between the Aid flow (current US$) in Australia and Aid flow (current US$) in Finland?
Make the answer very short. 1.30e+08. In the year 1999, what is the difference between the Aid flow (current US$) in Greece and Aid flow (current US$) in Luxembourg?
Provide a short and direct response. -8.20e+05. In the year 1999, what is the difference between the Aid flow (current US$) of Greece and Aid flow (current US$) of Australia?
Your answer should be compact. -1.21e+08. In the year 1999, what is the difference between the Aid flow (current US$) in Greece and Aid flow (current US$) in Finland?
Provide a succinct answer. 8.49e+06. In the year 1999, what is the difference between the Aid flow (current US$) in Luxembourg and Aid flow (current US$) in Australia?
Your answer should be very brief. -1.20e+08. In the year 1999, what is the difference between the Aid flow (current US$) in Luxembourg and Aid flow (current US$) in Finland?
Give a very brief answer. 9.31e+06. In the year 1999, what is the difference between the Aid flow (current US$) in Australia and Aid flow (current US$) in Finland?
Your answer should be very brief. 1.29e+08. In the year 2000, what is the difference between the Aid flow (current US$) in Greece and Aid flow (current US$) in Luxembourg?
Offer a very short reply. -3.09e+06. In the year 2000, what is the difference between the Aid flow (current US$) in Greece and Aid flow (current US$) in Australia?
Make the answer very short. -1.32e+08. In the year 2000, what is the difference between the Aid flow (current US$) of Greece and Aid flow (current US$) of Finland?
Make the answer very short. 7.96e+06. In the year 2000, what is the difference between the Aid flow (current US$) in Luxembourg and Aid flow (current US$) in Australia?
Provide a succinct answer. -1.29e+08. In the year 2000, what is the difference between the Aid flow (current US$) in Luxembourg and Aid flow (current US$) in Finland?
Keep it short and to the point. 1.10e+07. In the year 2000, what is the difference between the Aid flow (current US$) of Australia and Aid flow (current US$) of Finland?
Your response must be concise. 1.40e+08. In the year 2001, what is the difference between the Aid flow (current US$) in Greece and Aid flow (current US$) in Luxembourg?
Your answer should be compact. -6.81e+06. In the year 2001, what is the difference between the Aid flow (current US$) in Greece and Aid flow (current US$) in Australia?
Give a very brief answer. -1.69e+08. In the year 2001, what is the difference between the Aid flow (current US$) in Greece and Aid flow (current US$) in Finland?
Provide a succinct answer. 1.06e+06. In the year 2001, what is the difference between the Aid flow (current US$) of Luxembourg and Aid flow (current US$) of Australia?
Keep it short and to the point. -1.62e+08. In the year 2001, what is the difference between the Aid flow (current US$) of Luxembourg and Aid flow (current US$) of Finland?
Ensure brevity in your answer.  7.87e+06. In the year 2001, what is the difference between the Aid flow (current US$) in Australia and Aid flow (current US$) in Finland?
Your answer should be very brief. 1.70e+08. In the year 2002, what is the difference between the Aid flow (current US$) in Greece and Aid flow (current US$) in Luxembourg?
Offer a very short reply. -1.28e+07. In the year 2002, what is the difference between the Aid flow (current US$) in Greece and Aid flow (current US$) in Australia?
Provide a succinct answer. -1.61e+08. In the year 2002, what is the difference between the Aid flow (current US$) in Greece and Aid flow (current US$) in Finland?
Give a very brief answer. 1.65e+06. In the year 2002, what is the difference between the Aid flow (current US$) of Luxembourg and Aid flow (current US$) of Australia?
Offer a very short reply. -1.48e+08. In the year 2002, what is the difference between the Aid flow (current US$) in Luxembourg and Aid flow (current US$) in Finland?
Your answer should be compact. 1.45e+07. In the year 2002, what is the difference between the Aid flow (current US$) of Australia and Aid flow (current US$) of Finland?
Keep it short and to the point. 1.63e+08. In the year 2003, what is the difference between the Aid flow (current US$) of Greece and Aid flow (current US$) of Luxembourg?
Keep it short and to the point. -7.60e+05. In the year 2003, what is the difference between the Aid flow (current US$) of Greece and Aid flow (current US$) of Australia?
Provide a succinct answer. -1.99e+08. In the year 2003, what is the difference between the Aid flow (current US$) of Greece and Aid flow (current US$) of Finland?
Your response must be concise. 1.92e+07. In the year 2003, what is the difference between the Aid flow (current US$) in Luxembourg and Aid flow (current US$) in Australia?
Ensure brevity in your answer.  -1.98e+08. In the year 2003, what is the difference between the Aid flow (current US$) of Luxembourg and Aid flow (current US$) of Finland?
Provide a short and direct response. 2.00e+07. In the year 2003, what is the difference between the Aid flow (current US$) of Australia and Aid flow (current US$) of Finland?
Keep it short and to the point. 2.18e+08. What is the ratio of the Aid flow (current US$) of Greece in 1997 to that in 1998?
Your answer should be very brief. 0.49. What is the ratio of the Aid flow (current US$) of Luxembourg in 1997 to that in 1998?
Your response must be concise. 0.95. What is the ratio of the Aid flow (current US$) in Australia in 1997 to that in 1998?
Provide a succinct answer. 0.8. What is the ratio of the Aid flow (current US$) of Finland in 1997 to that in 1998?
Keep it short and to the point. 1.2. What is the ratio of the Aid flow (current US$) in Greece in 1997 to that in 1999?
Your answer should be very brief. 0.93. What is the ratio of the Aid flow (current US$) of Luxembourg in 1997 to that in 1999?
Make the answer very short. 0.45. What is the ratio of the Aid flow (current US$) in Australia in 1997 to that in 1999?
Provide a short and direct response. 0.8. What is the ratio of the Aid flow (current US$) of Finland in 1997 to that in 1999?
Provide a short and direct response. 0.58. What is the ratio of the Aid flow (current US$) in Greece in 1997 to that in 2000?
Your response must be concise. 0.86. What is the ratio of the Aid flow (current US$) of Luxembourg in 1997 to that in 2000?
Ensure brevity in your answer.  0.35. What is the ratio of the Aid flow (current US$) in Australia in 1997 to that in 2000?
Give a very brief answer. 0.73. What is the ratio of the Aid flow (current US$) of Finland in 1997 to that in 2000?
Your answer should be compact. 0.35. What is the ratio of the Aid flow (current US$) of Greece in 1997 to that in 2001?
Your answer should be very brief. 1.25. What is the ratio of the Aid flow (current US$) of Luxembourg in 1997 to that in 2001?
Make the answer very short. 0.35. What is the ratio of the Aid flow (current US$) in Australia in 1997 to that in 2001?
Ensure brevity in your answer.  0.59. What is the ratio of the Aid flow (current US$) of Finland in 1997 to that in 2001?
Keep it short and to the point. 0.17. What is the ratio of the Aid flow (current US$) of Greece in 1997 to that in 2002?
Ensure brevity in your answer.  0.95. What is the ratio of the Aid flow (current US$) in Luxembourg in 1997 to that in 2002?
Your answer should be very brief. 0.22. What is the ratio of the Aid flow (current US$) of Australia in 1997 to that in 2002?
Provide a succinct answer. 0.61. What is the ratio of the Aid flow (current US$) in Finland in 1997 to that in 2002?
Ensure brevity in your answer.  0.14. What is the ratio of the Aid flow (current US$) in Greece in 1997 to that in 2003?
Your answer should be very brief. 0.37. What is the ratio of the Aid flow (current US$) in Luxembourg in 1997 to that in 2003?
Offer a very short reply. 0.18. What is the ratio of the Aid flow (current US$) of Australia in 1997 to that in 2003?
Make the answer very short. 0.46. What is the ratio of the Aid flow (current US$) of Finland in 1997 to that in 2003?
Offer a terse response. 0.16. What is the ratio of the Aid flow (current US$) of Greece in 1998 to that in 1999?
Offer a terse response. 1.9. What is the ratio of the Aid flow (current US$) in Luxembourg in 1998 to that in 1999?
Offer a very short reply. 0.47. What is the ratio of the Aid flow (current US$) of Australia in 1998 to that in 1999?
Ensure brevity in your answer.  1. What is the ratio of the Aid flow (current US$) of Finland in 1998 to that in 1999?
Keep it short and to the point. 0.48. What is the ratio of the Aid flow (current US$) of Greece in 1998 to that in 2000?
Offer a terse response. 1.77. What is the ratio of the Aid flow (current US$) in Luxembourg in 1998 to that in 2000?
Offer a very short reply. 0.37. What is the ratio of the Aid flow (current US$) of Australia in 1998 to that in 2000?
Offer a terse response. 0.91. What is the ratio of the Aid flow (current US$) of Finland in 1998 to that in 2000?
Your answer should be compact. 0.29. What is the ratio of the Aid flow (current US$) of Greece in 1998 to that in 2001?
Give a very brief answer. 2.56. What is the ratio of the Aid flow (current US$) in Luxembourg in 1998 to that in 2001?
Your answer should be very brief. 0.36. What is the ratio of the Aid flow (current US$) of Australia in 1998 to that in 2001?
Your answer should be very brief. 0.74. What is the ratio of the Aid flow (current US$) of Finland in 1998 to that in 2001?
Keep it short and to the point. 0.14. What is the ratio of the Aid flow (current US$) in Greece in 1998 to that in 2002?
Offer a very short reply. 1.94. What is the ratio of the Aid flow (current US$) in Luxembourg in 1998 to that in 2002?
Give a very brief answer. 0.23. What is the ratio of the Aid flow (current US$) of Australia in 1998 to that in 2002?
Your answer should be very brief. 0.77. What is the ratio of the Aid flow (current US$) of Finland in 1998 to that in 2002?
Provide a short and direct response. 0.11. What is the ratio of the Aid flow (current US$) in Greece in 1998 to that in 2003?
Offer a terse response. 0.75. What is the ratio of the Aid flow (current US$) in Luxembourg in 1998 to that in 2003?
Your answer should be very brief. 0.19. What is the ratio of the Aid flow (current US$) in Australia in 1998 to that in 2003?
Your answer should be compact. 0.58. What is the ratio of the Aid flow (current US$) of Finland in 1998 to that in 2003?
Keep it short and to the point. 0.13. What is the ratio of the Aid flow (current US$) in Greece in 1999 to that in 2000?
Give a very brief answer. 0.93. What is the ratio of the Aid flow (current US$) of Luxembourg in 1999 to that in 2000?
Offer a terse response. 0.79. What is the ratio of the Aid flow (current US$) in Australia in 1999 to that in 2000?
Provide a short and direct response. 0.91. What is the ratio of the Aid flow (current US$) of Finland in 1999 to that in 2000?
Your response must be concise. 0.61. What is the ratio of the Aid flow (current US$) of Greece in 1999 to that in 2001?
Your answer should be compact. 1.34. What is the ratio of the Aid flow (current US$) of Luxembourg in 1999 to that in 2001?
Provide a short and direct response. 0.77. What is the ratio of the Aid flow (current US$) in Australia in 1999 to that in 2001?
Your answer should be very brief. 0.74. What is the ratio of the Aid flow (current US$) in Finland in 1999 to that in 2001?
Provide a short and direct response. 0.3. What is the ratio of the Aid flow (current US$) in Greece in 1999 to that in 2002?
Your answer should be very brief. 1.02. What is the ratio of the Aid flow (current US$) of Luxembourg in 1999 to that in 2002?
Your answer should be very brief. 0.49. What is the ratio of the Aid flow (current US$) of Australia in 1999 to that in 2002?
Your response must be concise. 0.76. What is the ratio of the Aid flow (current US$) of Finland in 1999 to that in 2002?
Provide a succinct answer. 0.24. What is the ratio of the Aid flow (current US$) of Greece in 1999 to that in 2003?
Offer a terse response. 0.39. What is the ratio of the Aid flow (current US$) of Luxembourg in 1999 to that in 2003?
Keep it short and to the point. 0.41. What is the ratio of the Aid flow (current US$) of Australia in 1999 to that in 2003?
Your response must be concise. 0.58. What is the ratio of the Aid flow (current US$) of Finland in 1999 to that in 2003?
Give a very brief answer. 0.27. What is the ratio of the Aid flow (current US$) in Greece in 2000 to that in 2001?
Your response must be concise. 1.44. What is the ratio of the Aid flow (current US$) in Luxembourg in 2000 to that in 2001?
Your answer should be compact. 0.98. What is the ratio of the Aid flow (current US$) in Australia in 2000 to that in 2001?
Give a very brief answer. 0.81. What is the ratio of the Aid flow (current US$) of Finland in 2000 to that in 2001?
Your response must be concise. 0.5. What is the ratio of the Aid flow (current US$) of Greece in 2000 to that in 2002?
Your answer should be compact. 1.1. What is the ratio of the Aid flow (current US$) in Luxembourg in 2000 to that in 2002?
Provide a succinct answer. 0.62. What is the ratio of the Aid flow (current US$) in Australia in 2000 to that in 2002?
Your answer should be very brief. 0.84. What is the ratio of the Aid flow (current US$) of Finland in 2000 to that in 2002?
Ensure brevity in your answer.  0.39. What is the ratio of the Aid flow (current US$) of Greece in 2000 to that in 2003?
Offer a terse response. 0.42. What is the ratio of the Aid flow (current US$) of Luxembourg in 2000 to that in 2003?
Give a very brief answer. 0.52. What is the ratio of the Aid flow (current US$) in Australia in 2000 to that in 2003?
Ensure brevity in your answer.  0.64. What is the ratio of the Aid flow (current US$) of Finland in 2000 to that in 2003?
Keep it short and to the point. 0.45. What is the ratio of the Aid flow (current US$) in Greece in 2001 to that in 2002?
Your answer should be very brief. 0.76. What is the ratio of the Aid flow (current US$) in Luxembourg in 2001 to that in 2002?
Make the answer very short. 0.63. What is the ratio of the Aid flow (current US$) in Australia in 2001 to that in 2002?
Your answer should be compact. 1.03. What is the ratio of the Aid flow (current US$) in Finland in 2001 to that in 2002?
Keep it short and to the point. 0.78. What is the ratio of the Aid flow (current US$) in Greece in 2001 to that in 2003?
Your answer should be very brief. 0.29. What is the ratio of the Aid flow (current US$) in Luxembourg in 2001 to that in 2003?
Ensure brevity in your answer.  0.53. What is the ratio of the Aid flow (current US$) of Australia in 2001 to that in 2003?
Keep it short and to the point. 0.78. What is the ratio of the Aid flow (current US$) in Finland in 2001 to that in 2003?
Make the answer very short. 0.91. What is the ratio of the Aid flow (current US$) of Greece in 2002 to that in 2003?
Make the answer very short. 0.39. What is the ratio of the Aid flow (current US$) of Luxembourg in 2002 to that in 2003?
Provide a short and direct response. 0.84. What is the ratio of the Aid flow (current US$) in Australia in 2002 to that in 2003?
Provide a succinct answer. 0.76. What is the ratio of the Aid flow (current US$) of Finland in 2002 to that in 2003?
Your answer should be very brief. 1.16. What is the difference between the highest and the second highest Aid flow (current US$) of Greece?
Your answer should be very brief. 6.68e+06. What is the difference between the highest and the second highest Aid flow (current US$) in Luxembourg?
Keep it short and to the point. 4.33e+06. What is the difference between the highest and the second highest Aid flow (current US$) in Australia?
Your answer should be compact. 4.93e+07. What is the difference between the highest and the second highest Aid flow (current US$) in Finland?
Keep it short and to the point. 1.20e+06. What is the difference between the highest and the lowest Aid flow (current US$) in Greece?
Offer a terse response. 1.89e+07. What is the difference between the highest and the lowest Aid flow (current US$) of Luxembourg?
Ensure brevity in your answer.  2.24e+07. What is the difference between the highest and the lowest Aid flow (current US$) in Australia?
Provide a short and direct response. 1.22e+08. What is the difference between the highest and the lowest Aid flow (current US$) in Finland?
Your answer should be compact. 7.72e+06. 